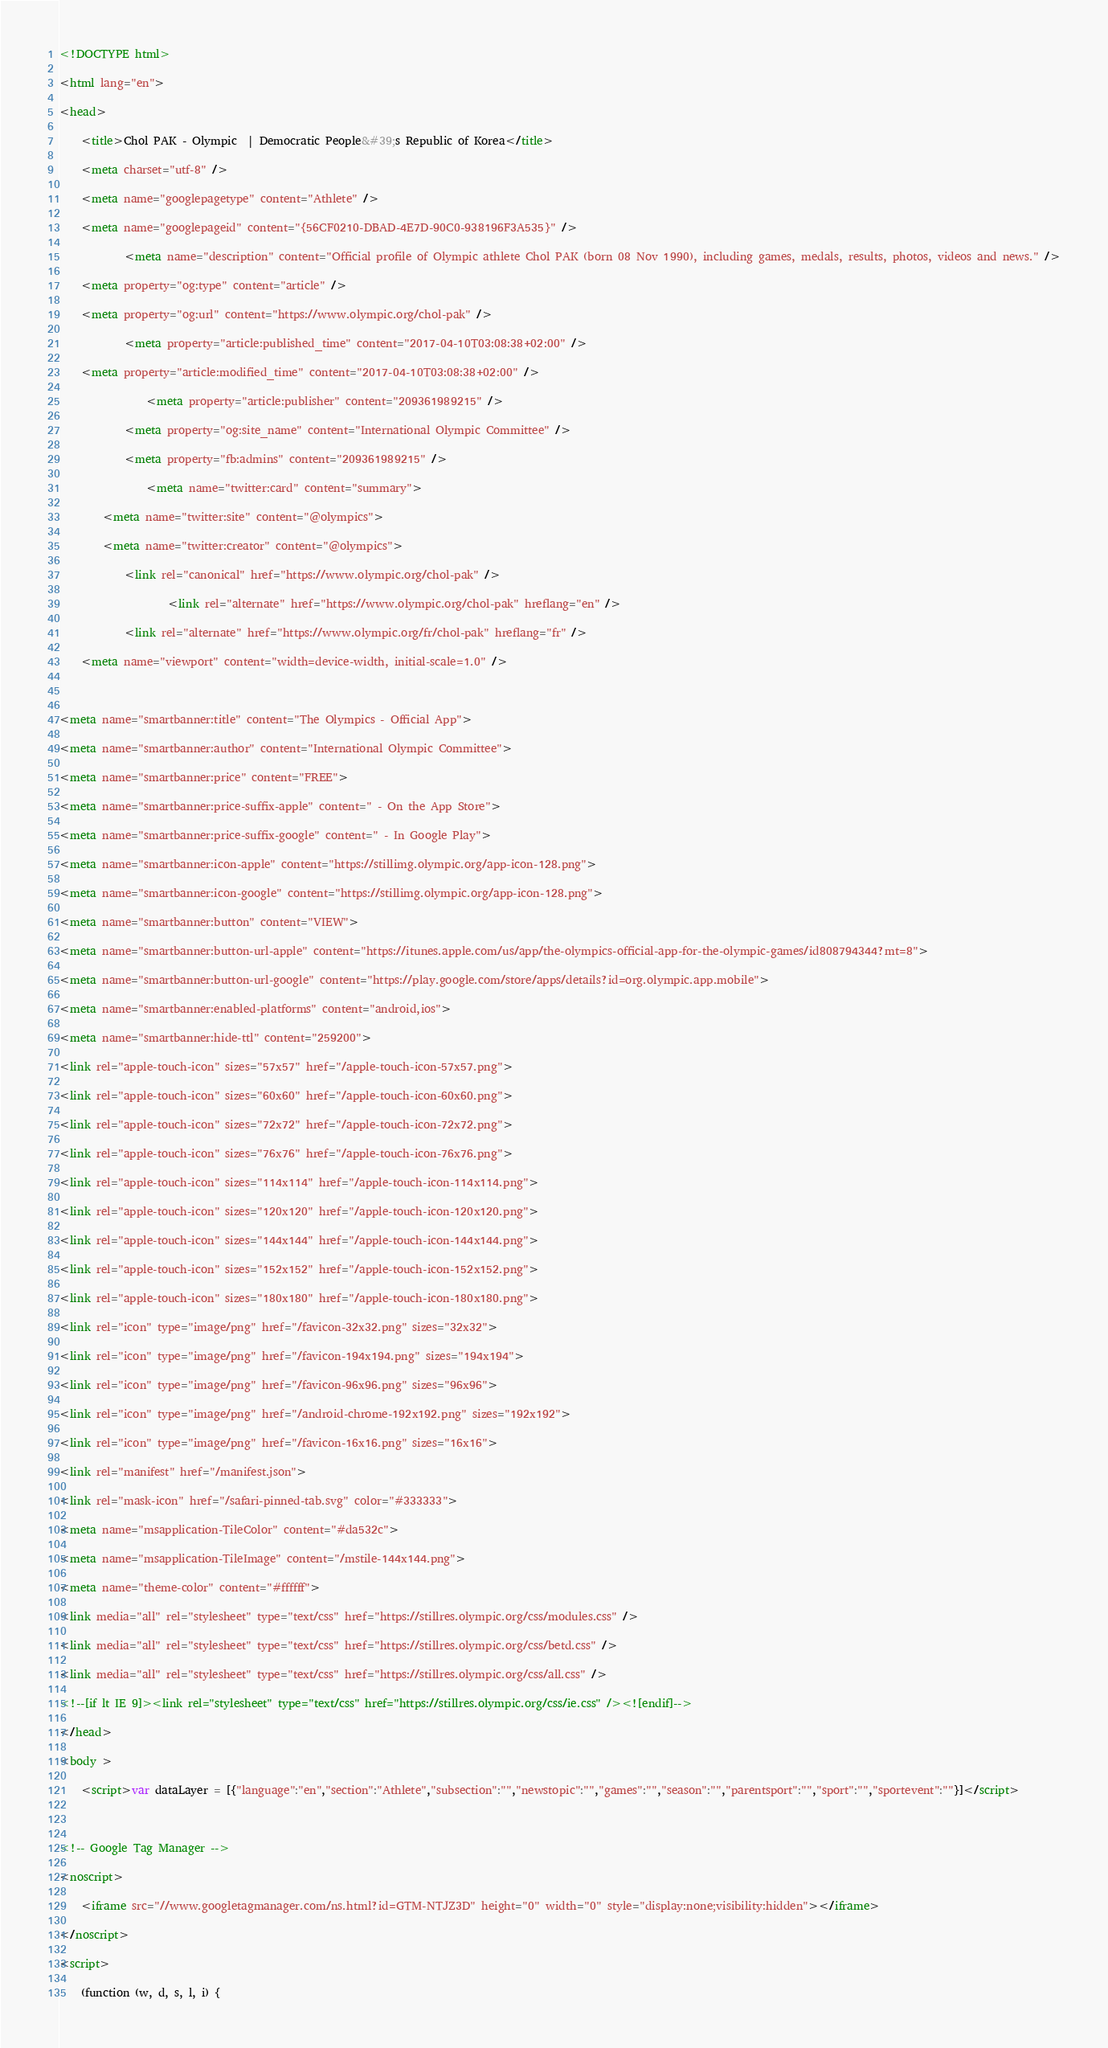Convert code to text. <code><loc_0><loc_0><loc_500><loc_500><_HTML_>
<!DOCTYPE html>
<html lang="en">
<head>
    <title>Chol PAK - Olympic  | Democratic People&#39;s Republic of Korea</title>
    <meta charset="utf-8" />
    <meta name="googlepagetype" content="Athlete" />
    <meta name="googlepageid" content="{56CF0210-DBAD-4E7D-90C0-938196F3A535}" />
            <meta name="description" content="Official profile of Olympic athlete Chol PAK (born 08 Nov 1990), including games, medals, results, photos, videos and news." />
    <meta property="og:type" content="article" />
    <meta property="og:url" content="https://www.olympic.org/chol-pak" />
            <meta property="article:published_time" content="2017-04-10T03:08:38+02:00" />
    <meta property="article:modified_time" content="2017-04-10T03:08:38+02:00" />
                <meta property="article:publisher" content="209361989215" />
            <meta property="og:site_name" content="International Olympic Committee" />
            <meta property="fb:admins" content="209361989215" />
                <meta name="twitter:card" content="summary">
        <meta name="twitter:site" content="@olympics">
        <meta name="twitter:creator" content="@olympics">
            <link rel="canonical" href="https://www.olympic.org/chol-pak" />
                    <link rel="alternate" href="https://www.olympic.org/chol-pak" hreflang="en" />
            <link rel="alternate" href="https://www.olympic.org/fr/chol-pak" hreflang="fr" />
    <meta name="viewport" content="width=device-width, initial-scale=1.0" />

<meta name="smartbanner:title" content="The Olympics - Official App">
<meta name="smartbanner:author" content="International Olympic Committee">
<meta name="smartbanner:price" content="FREE">
<meta name="smartbanner:price-suffix-apple" content=" - On the App Store">
<meta name="smartbanner:price-suffix-google" content=" - In Google Play">
<meta name="smartbanner:icon-apple" content="https://stillimg.olympic.org/app-icon-128.png">
<meta name="smartbanner:icon-google" content="https://stillimg.olympic.org/app-icon-128.png">
<meta name="smartbanner:button" content="VIEW">
<meta name="smartbanner:button-url-apple" content="https://itunes.apple.com/us/app/the-olympics-official-app-for-the-olympic-games/id808794344?mt=8">
<meta name="smartbanner:button-url-google" content="https://play.google.com/store/apps/details?id=org.olympic.app.mobile">
<meta name="smartbanner:enabled-platforms" content="android,ios">
<meta name="smartbanner:hide-ttl" content="259200">
<link rel="apple-touch-icon" sizes="57x57" href="/apple-touch-icon-57x57.png">
<link rel="apple-touch-icon" sizes="60x60" href="/apple-touch-icon-60x60.png">
<link rel="apple-touch-icon" sizes="72x72" href="/apple-touch-icon-72x72.png">
<link rel="apple-touch-icon" sizes="76x76" href="/apple-touch-icon-76x76.png">
<link rel="apple-touch-icon" sizes="114x114" href="/apple-touch-icon-114x114.png">
<link rel="apple-touch-icon" sizes="120x120" href="/apple-touch-icon-120x120.png">
<link rel="apple-touch-icon" sizes="144x144" href="/apple-touch-icon-144x144.png">
<link rel="apple-touch-icon" sizes="152x152" href="/apple-touch-icon-152x152.png">
<link rel="apple-touch-icon" sizes="180x180" href="/apple-touch-icon-180x180.png">
<link rel="icon" type="image/png" href="/favicon-32x32.png" sizes="32x32">
<link rel="icon" type="image/png" href="/favicon-194x194.png" sizes="194x194">
<link rel="icon" type="image/png" href="/favicon-96x96.png" sizes="96x96">
<link rel="icon" type="image/png" href="/android-chrome-192x192.png" sizes="192x192">
<link rel="icon" type="image/png" href="/favicon-16x16.png" sizes="16x16">
<link rel="manifest" href="/manifest.json">
<link rel="mask-icon" href="/safari-pinned-tab.svg" color="#333333">
<meta name="msapplication-TileColor" content="#da532c">
<meta name="msapplication-TileImage" content="/mstile-144x144.png">
<meta name="theme-color" content="#ffffff">
<link media="all" rel="stylesheet" type="text/css" href="https://stillres.olympic.org/css/modules.css" />
<link media="all" rel="stylesheet" type="text/css" href="https://stillres.olympic.org/css/betd.css" />
<link media="all" rel="stylesheet" type="text/css" href="https://stillres.olympic.org/css/all.css" />
<!--[if lt IE 9]><link rel="stylesheet" type="text/css" href="https://stillres.olympic.org/css/ie.css" /><![endif]-->
</head>
<body >
    <script>var dataLayer = [{"language":"en","section":"Athlete","subsection":"","newstopic":"","games":"","season":"","parentsport":"","sport":"","sportevent":""}]</script>
    
<!-- Google Tag Manager -->
<noscript>
    <iframe src="//www.googletagmanager.com/ns.html?id=GTM-NTJZ3D" height="0" width="0" style="display:none;visibility:hidden"></iframe>
</noscript>
<script>
    (function (w, d, s, l, i) {</code> 